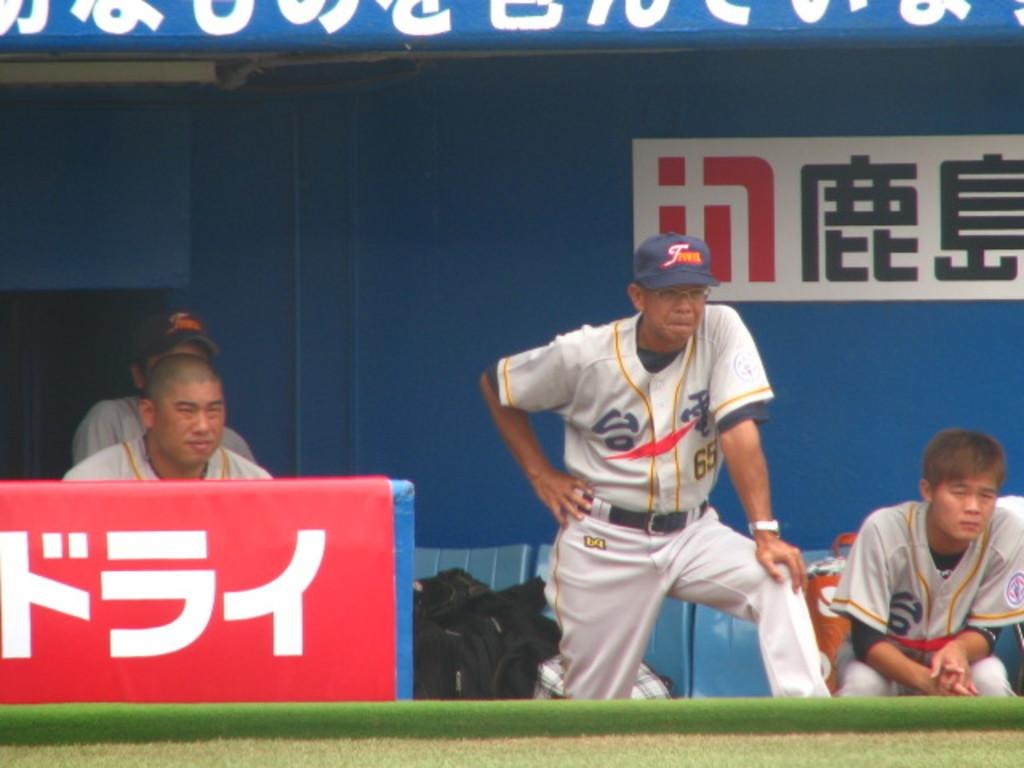<image>
Present a compact description of the photo's key features. Japanese baseball players watch the game from the dugout. 